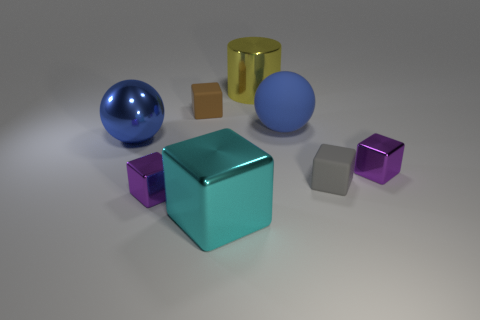Does the big rubber sphere have the same color as the metal sphere?
Give a very brief answer. Yes. How many things are either tiny metallic cubes right of the small brown cube or big things that are in front of the yellow cylinder?
Ensure brevity in your answer.  4. How many other objects are there of the same material as the small gray block?
Make the answer very short. 2. Does the big ball to the right of the cyan metal thing have the same material as the big cyan block?
Provide a succinct answer. No. Is the number of big yellow metallic objects left of the big blue matte sphere greater than the number of purple metal objects behind the shiny ball?
Provide a succinct answer. Yes. What number of objects are either blocks behind the gray matte thing or large blue balls?
Your answer should be compact. 4. There is a blue object that is the same material as the cyan object; what shape is it?
Your answer should be very brief. Sphere. Are there any other things that are the same shape as the yellow thing?
Ensure brevity in your answer.  No. What is the color of the matte thing that is on the left side of the small gray matte object and on the right side of the yellow metallic thing?
Provide a short and direct response. Blue. How many blocks are either purple objects or blue metallic objects?
Offer a very short reply. 2. 